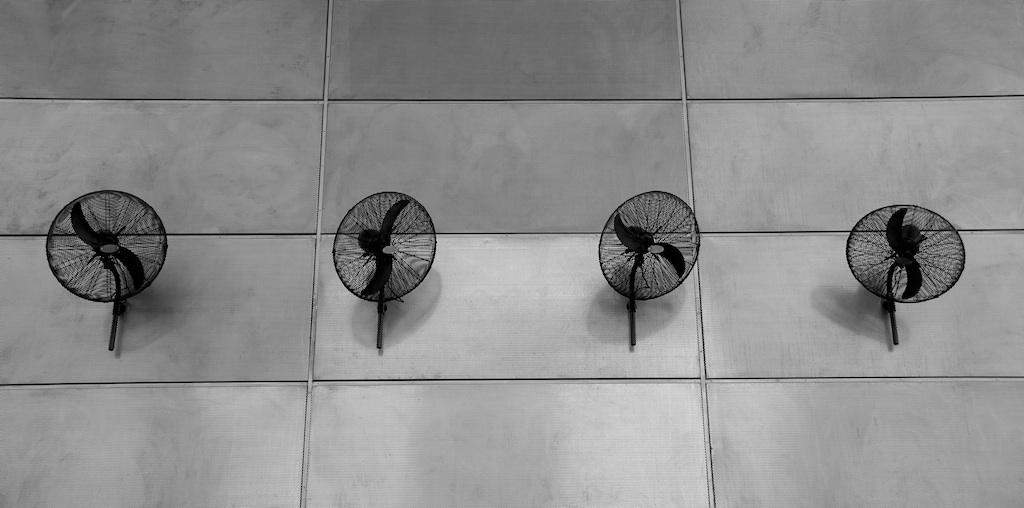How many fans can be seen in the image? There are four fans in the image. Where are the fans located in the image? The fans are mounted on the walls. What type of throat relief can be seen in the image? There is no throat relief present in the image; it features four fans mounted on the walls. What unit of measurement is used to determine the size of the fans in the image? The size of the fans is not specified in the image, so it is not possible to determine the unit of measurement used. 